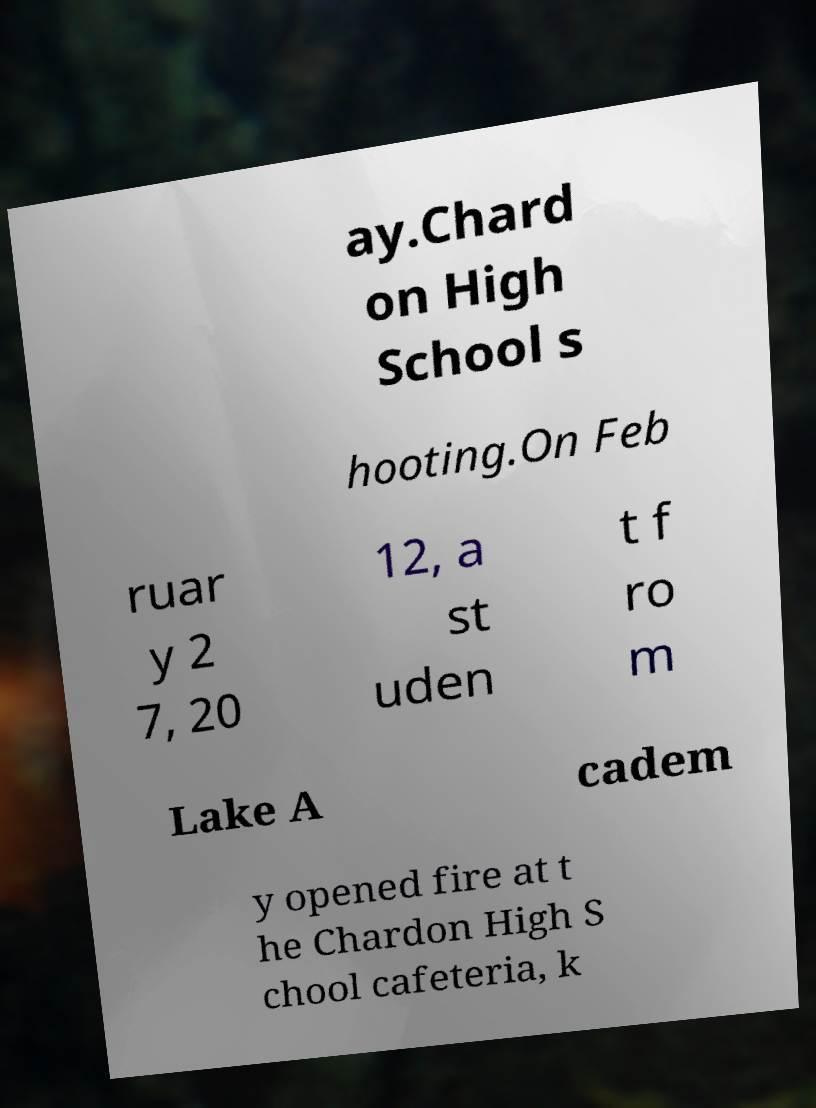What messages or text are displayed in this image? I need them in a readable, typed format. ay.Chard on High School s hooting.On Feb ruar y 2 7, 20 12, a st uden t f ro m Lake A cadem y opened fire at t he Chardon High S chool cafeteria, k 